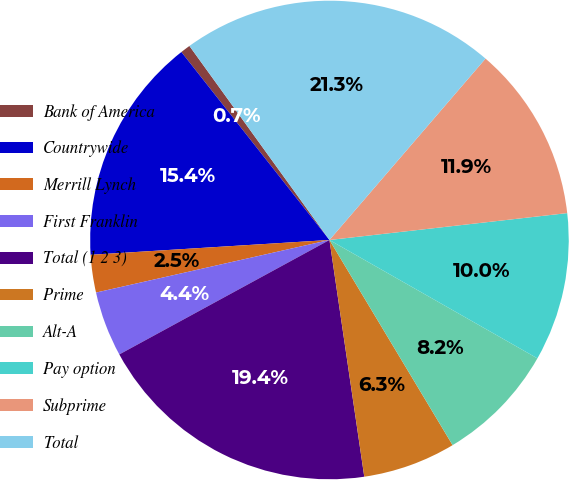Convert chart to OTSL. <chart><loc_0><loc_0><loc_500><loc_500><pie_chart><fcel>Bank of America<fcel>Countrywide<fcel>Merrill Lynch<fcel>First Franklin<fcel>Total (1 2 3)<fcel>Prime<fcel>Alt-A<fcel>Pay option<fcel>Subprime<fcel>Total<nl><fcel>0.67%<fcel>15.37%<fcel>2.54%<fcel>4.41%<fcel>19.39%<fcel>6.28%<fcel>8.16%<fcel>10.03%<fcel>11.9%<fcel>21.26%<nl></chart> 